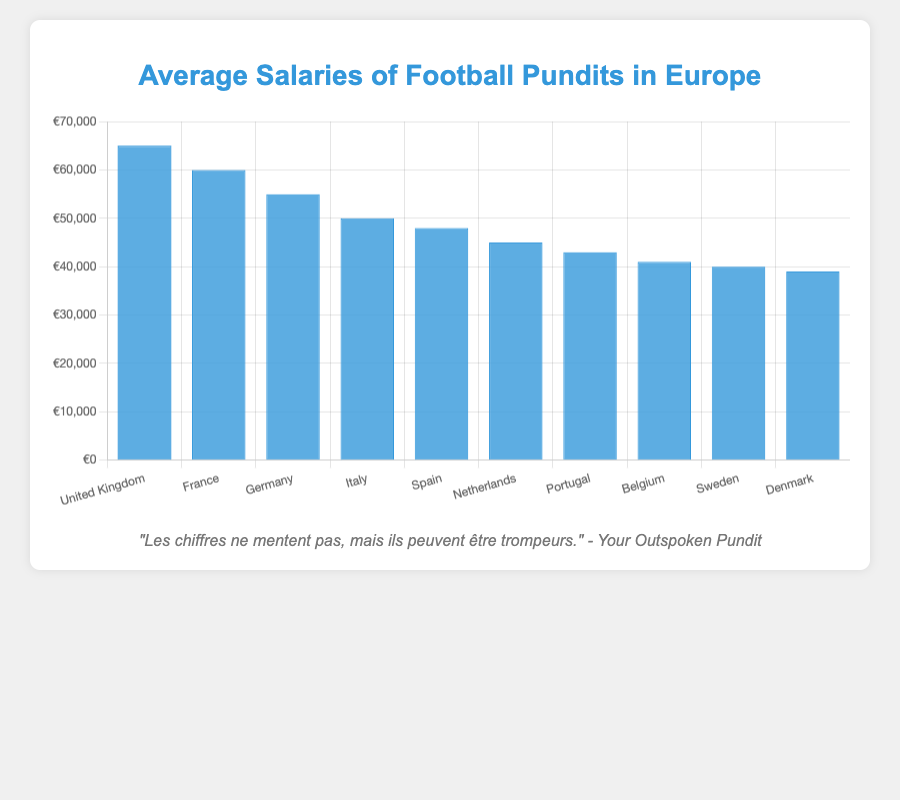what country has the highest average salary for football pundits? The bar chart shows that the United Kingdom has the highest bar, indicating the highest average salary for football pundits.
Answer: United Kingdom Which country has a higher average salary for football pundits, France or Germany? By comparing the heights of the bars for France and Germany, France has a higher bar, indicating a higher average salary.
Answer: France What is the difference in average salary between the highest (United Kingdom) and the lowest (Denmark)? The average salary for the United Kingdom is €65,000 and for Denmark is €39,000. The difference is calculated as €65,000 - €39,000.
Answer: €26,000 How many countries have an average salary of €50,000 or more? By counting the bars that reach or exceed the €50,000 mark: United Kingdom, France, Germany, and Italy.
Answer: 4 What is the average salary of the three countries with the lowest figures? The three countries with the lowest average salaries are Denmark (€39,000), Sweden (€40,000), and Belgium (€41,000). The average is calculated as (€39,000 + €40,000 + €41,000) / 3.
Answer: €40,000 What is the total combined average salary for football pundits in Spain, Netherlands, and Portugal? Summing the average salaries for Spain (€48,000), Netherlands (€45,000), and Portugal (€43,000).
Answer: €136,000 Which two countries have the closest average salaries and what are those salaries? By comparing the bars visually, Sweden and Denmark have bars close to each other. Sweden has €40,000 and Denmark has €39,000.
Answer: Sweden: €40,000 and Denmark: €39,000 Order the countries from the highest to the lowest average salary. Observing the chart and listing the countries according to the height of the bars: United Kingdom, France, Germany, Italy, Spain, Netherlands, Portugal, Belgium, Sweden, Denmark.
Answer: United Kingdom, France, Germany, Italy, Spain, Netherlands, Portugal, Belgium, Sweden, Denmark What is the percentage difference in average salary between Germany and Italy? The average salary for Germany is €55,000 and for Italy is €50,000. The difference is €55,000 - €50,000 = €5,000. The percentage difference is (€5,000 / €55,000) * 100%.
Answer: ~9.09% If the average salary in the Netherlands increased by 10%, what would it be? The average salary in the Netherlands is €45,000. Increasing by 10% means €45,000 * 1.10.
Answer: €49,500 